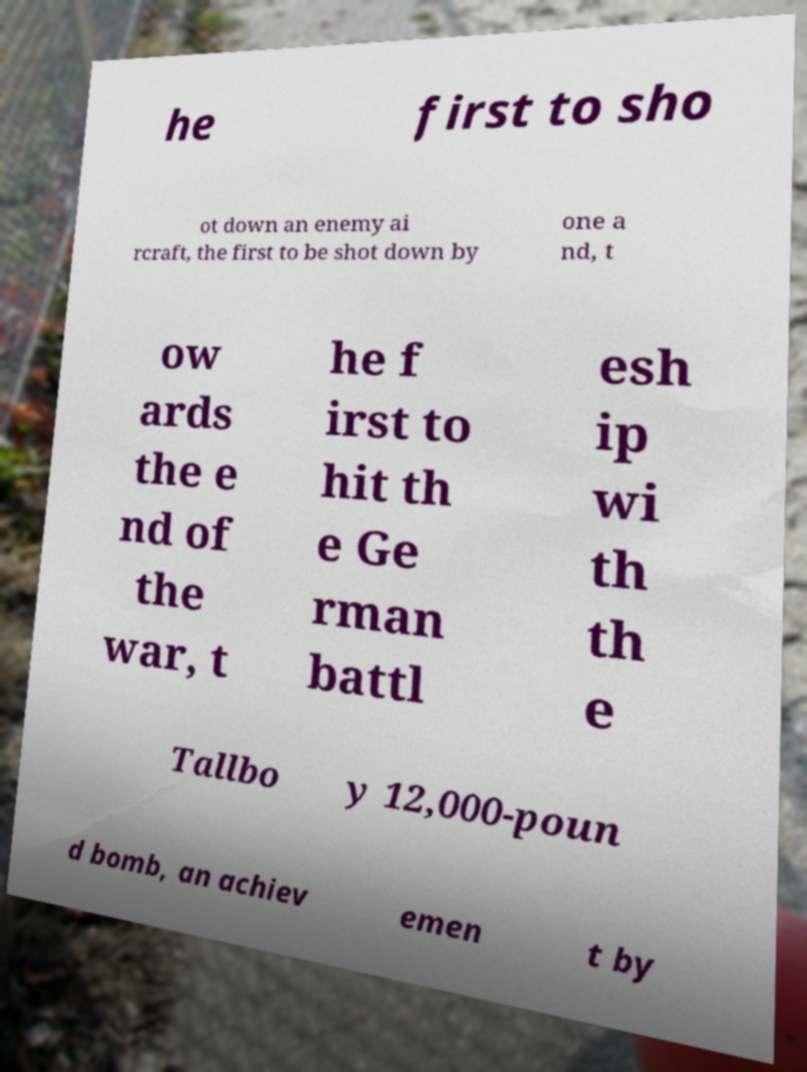Can you read and provide the text displayed in the image?This photo seems to have some interesting text. Can you extract and type it out for me? he first to sho ot down an enemy ai rcraft, the first to be shot down by one a nd, t ow ards the e nd of the war, t he f irst to hit th e Ge rman battl esh ip wi th th e Tallbo y 12,000-poun d bomb, an achiev emen t by 